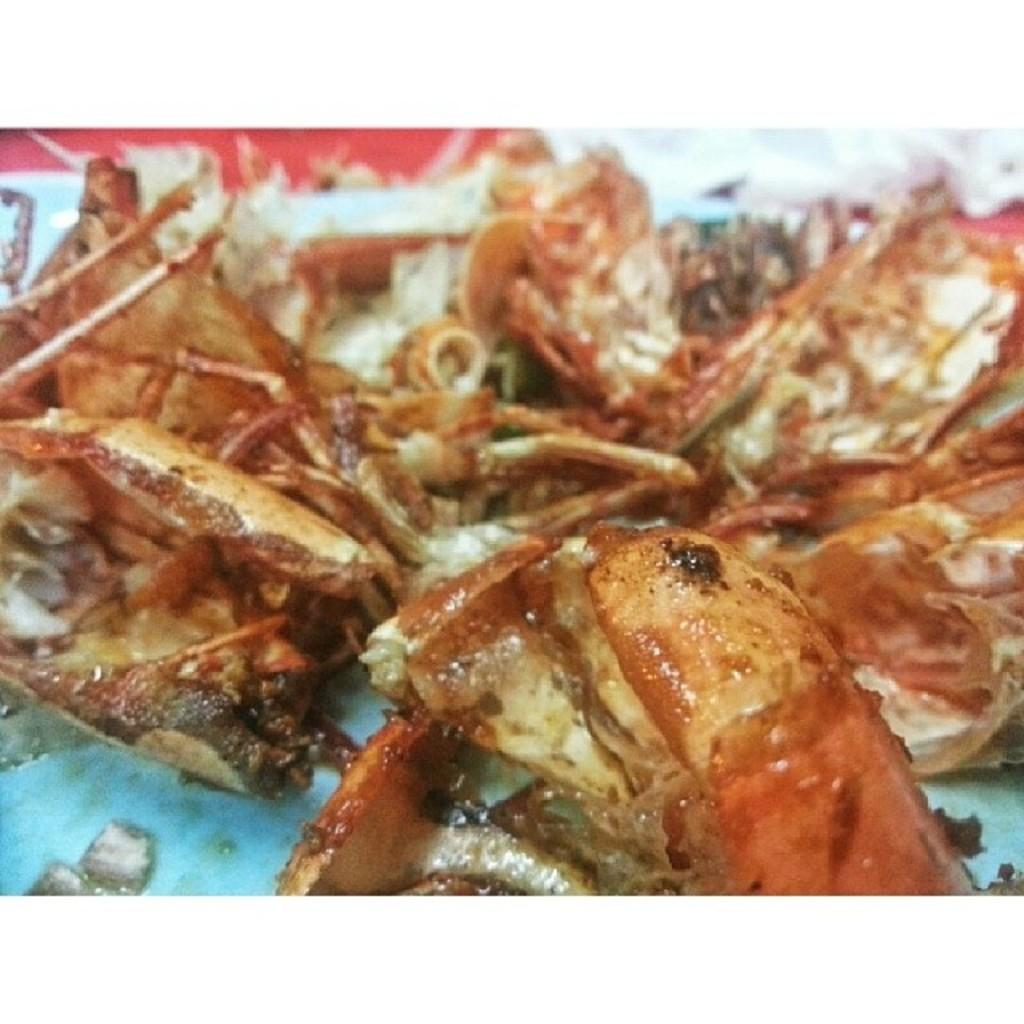What is the focus of the image? The image is zoomed in. What can be seen in the image? There are food items in the image. Where are the food items located? The food items are placed on the surface of an object. How many books are stacked on top of the cows in the image? There are no books or cows present in the image; it only features food items placed on the surface of an object. 